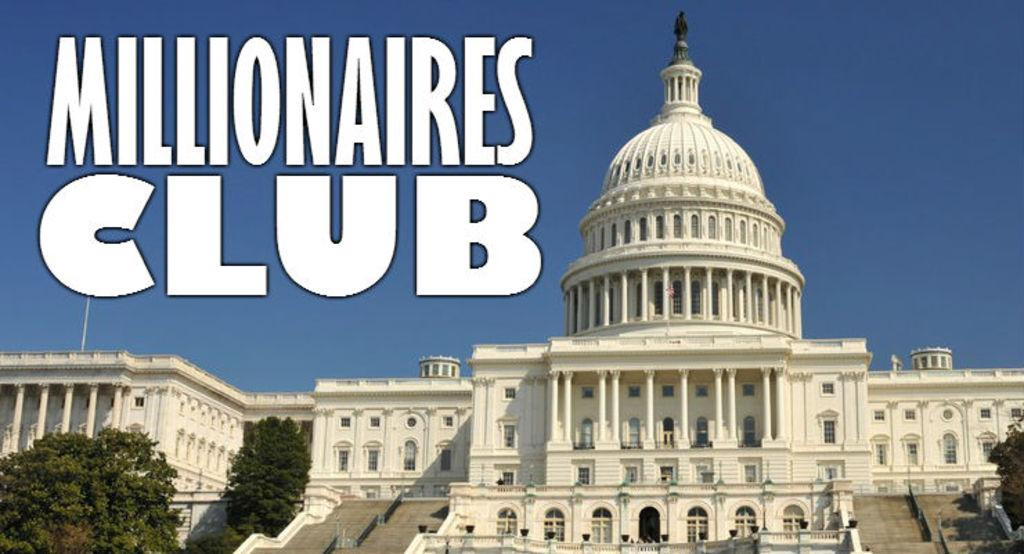What type of structure is present in the image? There is a building in the image. What other natural elements can be seen in the image? There are trees in the image. What is visible at the top of the image? The sky is visible at the top of the image. What might be used for reading or understanding information in the image? There is some text in the image. What architectural feature is located at the bottom of the image? There is a staircase at the bottom of the image. How many apples are hanging from the trees in the image? There are no apples present in the image; only trees are visible. What instruction is given to the person in the image to stop doing something? There is no person or instruction to stop doing something in the image. 